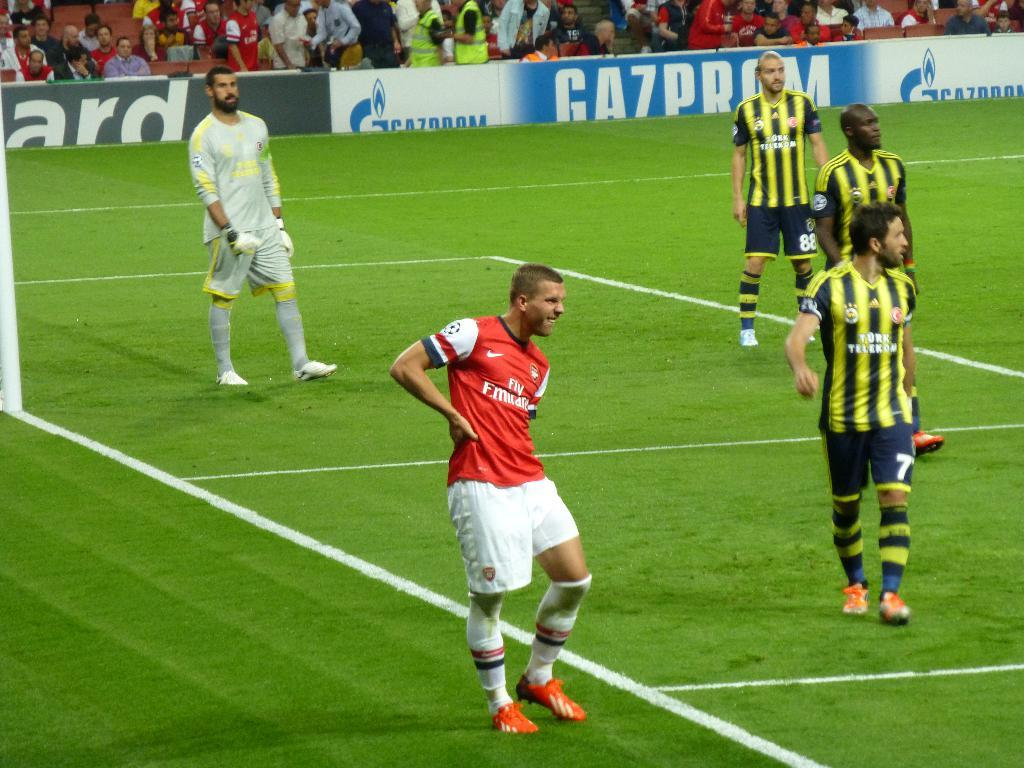Provide a one-sentence caption for the provided image. Soccer players standing on a field during a game in front of ads for Gazprom. 